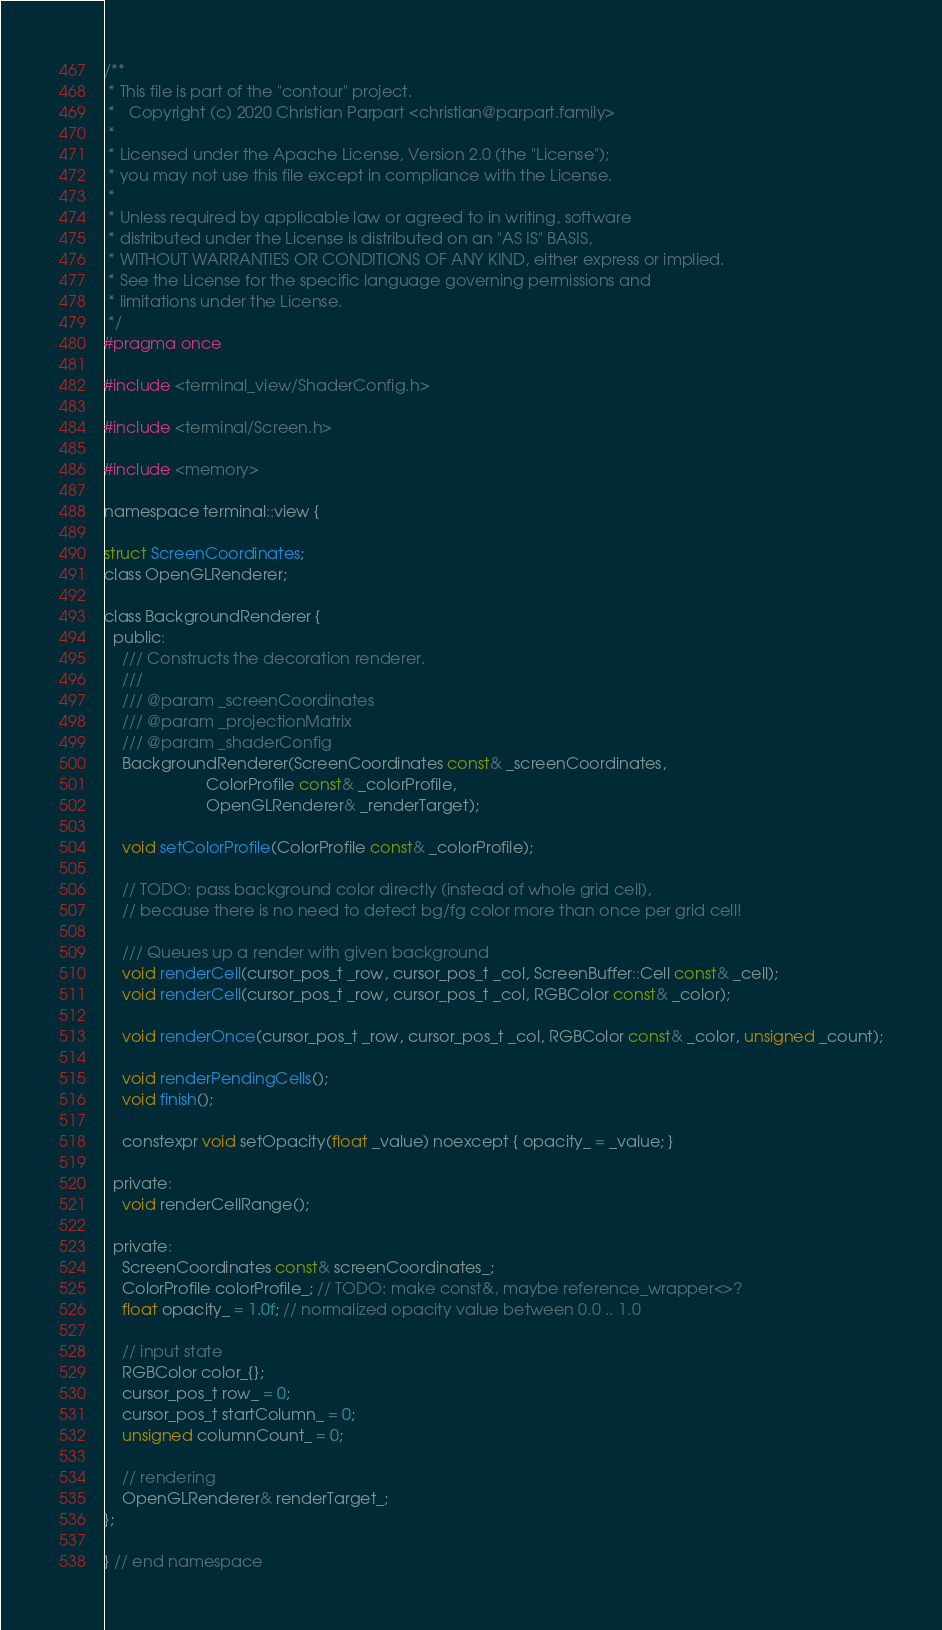Convert code to text. <code><loc_0><loc_0><loc_500><loc_500><_C_>/**
 * This file is part of the "contour" project.
 *   Copyright (c) 2020 Christian Parpart <christian@parpart.family>
 *
 * Licensed under the Apache License, Version 2.0 (the "License");
 * you may not use this file except in compliance with the License.
 *
 * Unless required by applicable law or agreed to in writing, software
 * distributed under the License is distributed on an "AS IS" BASIS,
 * WITHOUT WARRANTIES OR CONDITIONS OF ANY KIND, either express or implied.
 * See the License for the specific language governing permissions and
 * limitations under the License.
 */
#pragma once

#include <terminal_view/ShaderConfig.h>

#include <terminal/Screen.h>

#include <memory>

namespace terminal::view {

struct ScreenCoordinates;
class OpenGLRenderer;

class BackgroundRenderer {
  public:
    /// Constructs the decoration renderer.
    ///
    /// @param _screenCoordinates
    /// @param _projectionMatrix
    /// @param _shaderConfig
    BackgroundRenderer(ScreenCoordinates const& _screenCoordinates,
                       ColorProfile const& _colorProfile,
                       OpenGLRenderer& _renderTarget);

    void setColorProfile(ColorProfile const& _colorProfile);

    // TODO: pass background color directly (instead of whole grid cell),
    // because there is no need to detect bg/fg color more than once per grid cell!

    /// Queues up a render with given background
    void renderCell(cursor_pos_t _row, cursor_pos_t _col, ScreenBuffer::Cell const& _cell);
    void renderCell(cursor_pos_t _row, cursor_pos_t _col, RGBColor const& _color);

    void renderOnce(cursor_pos_t _row, cursor_pos_t _col, RGBColor const& _color, unsigned _count);

    void renderPendingCells();
    void finish();

    constexpr void setOpacity(float _value) noexcept { opacity_ = _value; }

  private:
    void renderCellRange();

  private:
    ScreenCoordinates const& screenCoordinates_;
    ColorProfile colorProfile_; // TODO: make const&, maybe reference_wrapper<>?
    float opacity_ = 1.0f; // normalized opacity value between 0.0 .. 1.0

    // input state
    RGBColor color_{};
    cursor_pos_t row_ = 0;
    cursor_pos_t startColumn_ = 0;
    unsigned columnCount_ = 0;

    // rendering
    OpenGLRenderer& renderTarget_;
};

} // end namespace
</code> 